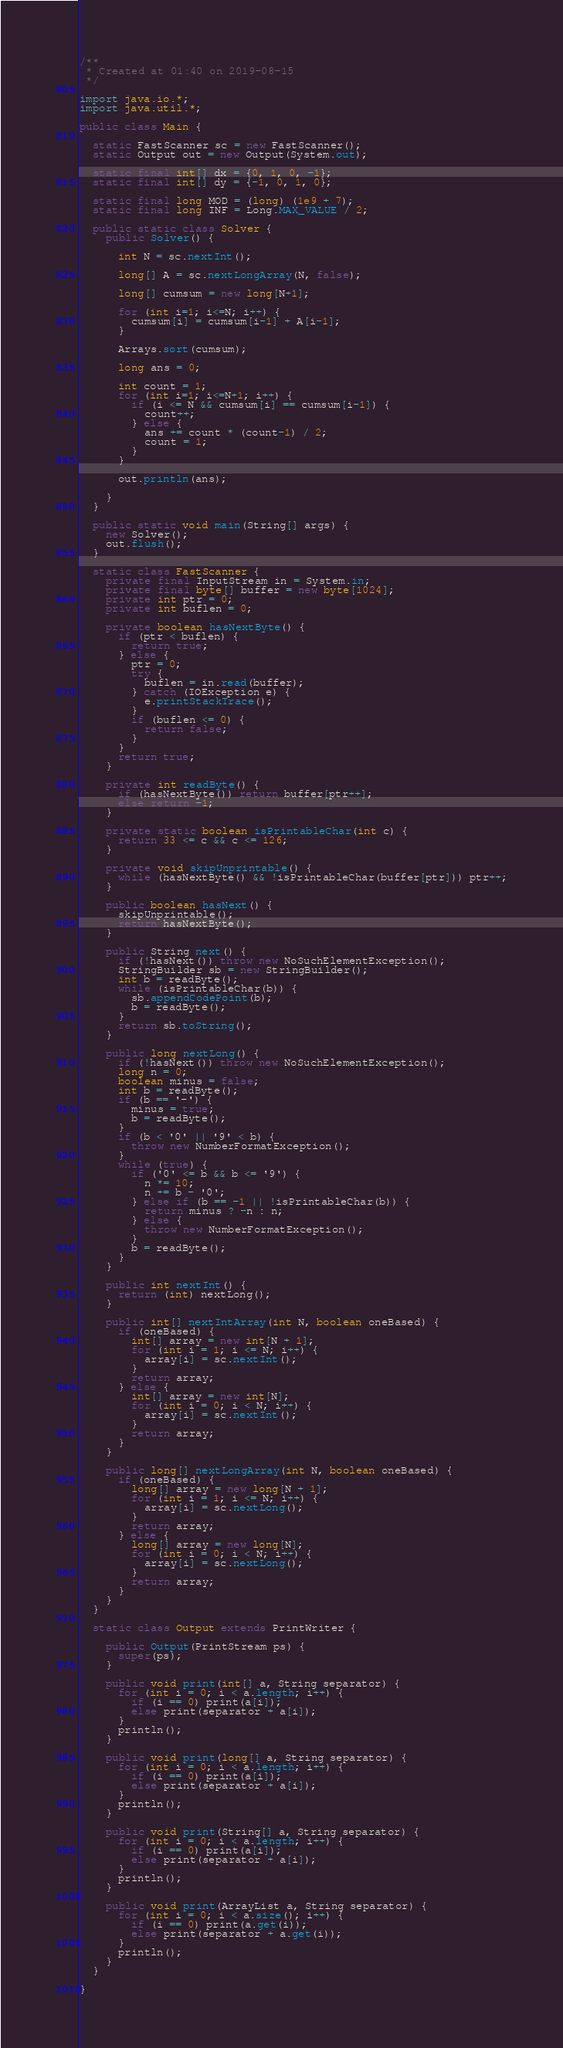<code> <loc_0><loc_0><loc_500><loc_500><_Java_>/**
 * Created at 01:40 on 2019-08-15
 */

import java.io.*;
import java.util.*;

public class Main {

  static FastScanner sc = new FastScanner();
  static Output out = new Output(System.out);

  static final int[] dx = {0, 1, 0, -1};
  static final int[] dy = {-1, 0, 1, 0};

  static final long MOD = (long) (1e9 + 7);
  static final long INF = Long.MAX_VALUE / 2;

  public static class Solver {
    public Solver() {

      int N = sc.nextInt();

      long[] A = sc.nextLongArray(N, false);

      long[] cumsum = new long[N+1];

      for (int i=1; i<=N; i++) {
        cumsum[i] = cumsum[i-1] + A[i-1];
      }

      Arrays.sort(cumsum);

      long ans = 0;

      int count = 1;
      for (int i=1; i<=N+1; i++) {
        if (i <= N && cumsum[i] == cumsum[i-1]) {
          count++;
        } else {
          ans += count * (count-1) / 2;
          count = 1;
        }
      }

      out.println(ans);

    }
  }

  public static void main(String[] args) {
    new Solver();
    out.flush();
  }

  static class FastScanner {
    private final InputStream in = System.in;
    private final byte[] buffer = new byte[1024];
    private int ptr = 0;
    private int buflen = 0;

    private boolean hasNextByte() {
      if (ptr < buflen) {
        return true;
      } else {
        ptr = 0;
        try {
          buflen = in.read(buffer);
        } catch (IOException e) {
          e.printStackTrace();
        }
        if (buflen <= 0) {
          return false;
        }
      }
      return true;
    }

    private int readByte() {
      if (hasNextByte()) return buffer[ptr++];
      else return -1;
    }

    private static boolean isPrintableChar(int c) {
      return 33 <= c && c <= 126;
    }

    private void skipUnprintable() {
      while (hasNextByte() && !isPrintableChar(buffer[ptr])) ptr++;
    }

    public boolean hasNext() {
      skipUnprintable();
      return hasNextByte();
    }

    public String next() {
      if (!hasNext()) throw new NoSuchElementException();
      StringBuilder sb = new StringBuilder();
      int b = readByte();
      while (isPrintableChar(b)) {
        sb.appendCodePoint(b);
        b = readByte();
      }
      return sb.toString();
    }

    public long nextLong() {
      if (!hasNext()) throw new NoSuchElementException();
      long n = 0;
      boolean minus = false;
      int b = readByte();
      if (b == '-') {
        minus = true;
        b = readByte();
      }
      if (b < '0' || '9' < b) {
        throw new NumberFormatException();
      }
      while (true) {
        if ('0' <= b && b <= '9') {
          n *= 10;
          n += b - '0';
        } else if (b == -1 || !isPrintableChar(b)) {
          return minus ? -n : n;
        } else {
          throw new NumberFormatException();
        }
        b = readByte();
      }
    }

    public int nextInt() {
      return (int) nextLong();
    }

    public int[] nextIntArray(int N, boolean oneBased) {
      if (oneBased) {
        int[] array = new int[N + 1];
        for (int i = 1; i <= N; i++) {
          array[i] = sc.nextInt();
        }
        return array;
      } else {
        int[] array = new int[N];
        for (int i = 0; i < N; i++) {
          array[i] = sc.nextInt();
        }
        return array;
      }
    }

    public long[] nextLongArray(int N, boolean oneBased) {
      if (oneBased) {
        long[] array = new long[N + 1];
        for (int i = 1; i <= N; i++) {
          array[i] = sc.nextLong();
        }
        return array;
      } else {
        long[] array = new long[N];
        for (int i = 0; i < N; i++) {
          array[i] = sc.nextLong();
        }
        return array;
      }
    }
  }

  static class Output extends PrintWriter {

    public Output(PrintStream ps) {
      super(ps);
    }

    public void print(int[] a, String separator) {
      for (int i = 0; i < a.length; i++) {
        if (i == 0) print(a[i]);
        else print(separator + a[i]);
      }
      println();
    }

    public void print(long[] a, String separator) {
      for (int i = 0; i < a.length; i++) {
        if (i == 0) print(a[i]);
        else print(separator + a[i]);
      }
      println();
    }

    public void print(String[] a, String separator) {
      for (int i = 0; i < a.length; i++) {
        if (i == 0) print(a[i]);
        else print(separator + a[i]);
      }
      println();
    }

    public void print(ArrayList a, String separator) {
      for (int i = 0; i < a.size(); i++) {
        if (i == 0) print(a.get(i));
        else print(separator + a.get(i));
      }
      println();
    }
  }

}
</code> 